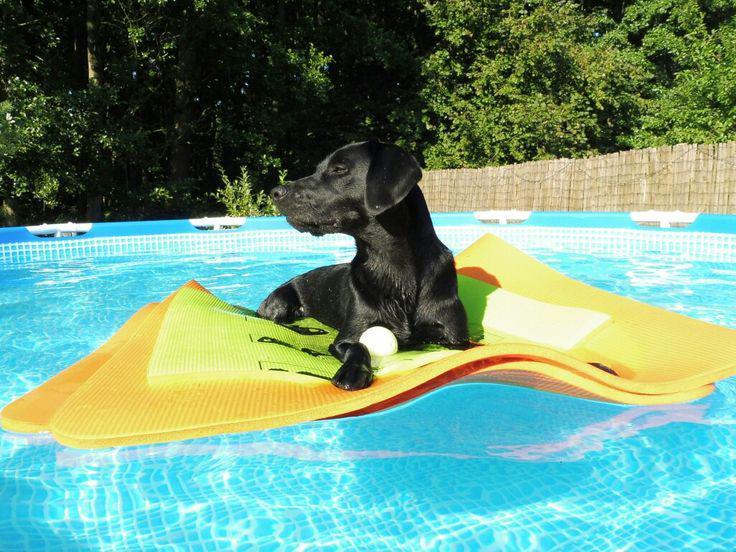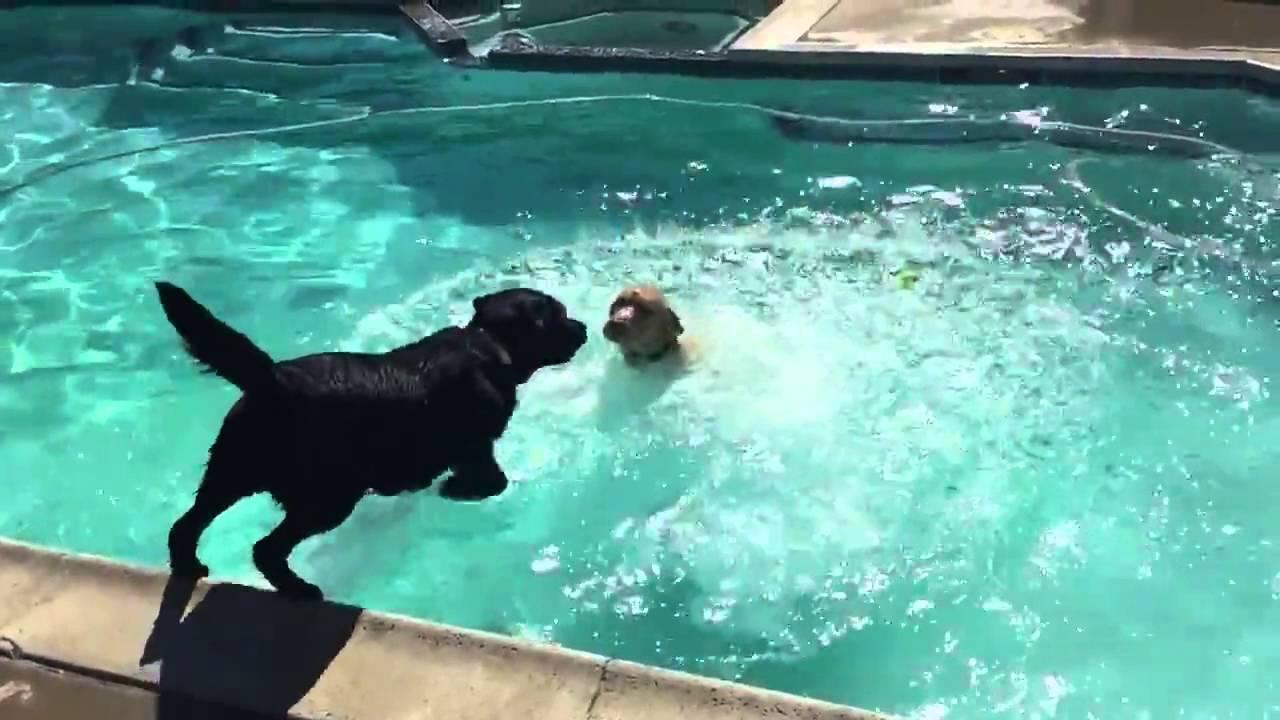The first image is the image on the left, the second image is the image on the right. Assess this claim about the two images: "A black dog is floating on something yellow in a pool.". Correct or not? Answer yes or no. Yes. 